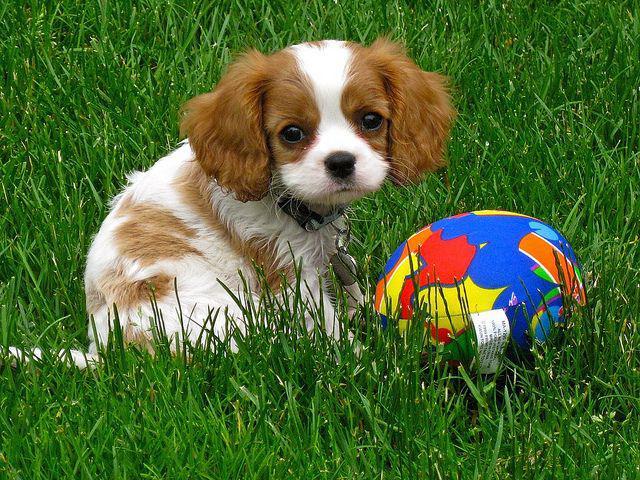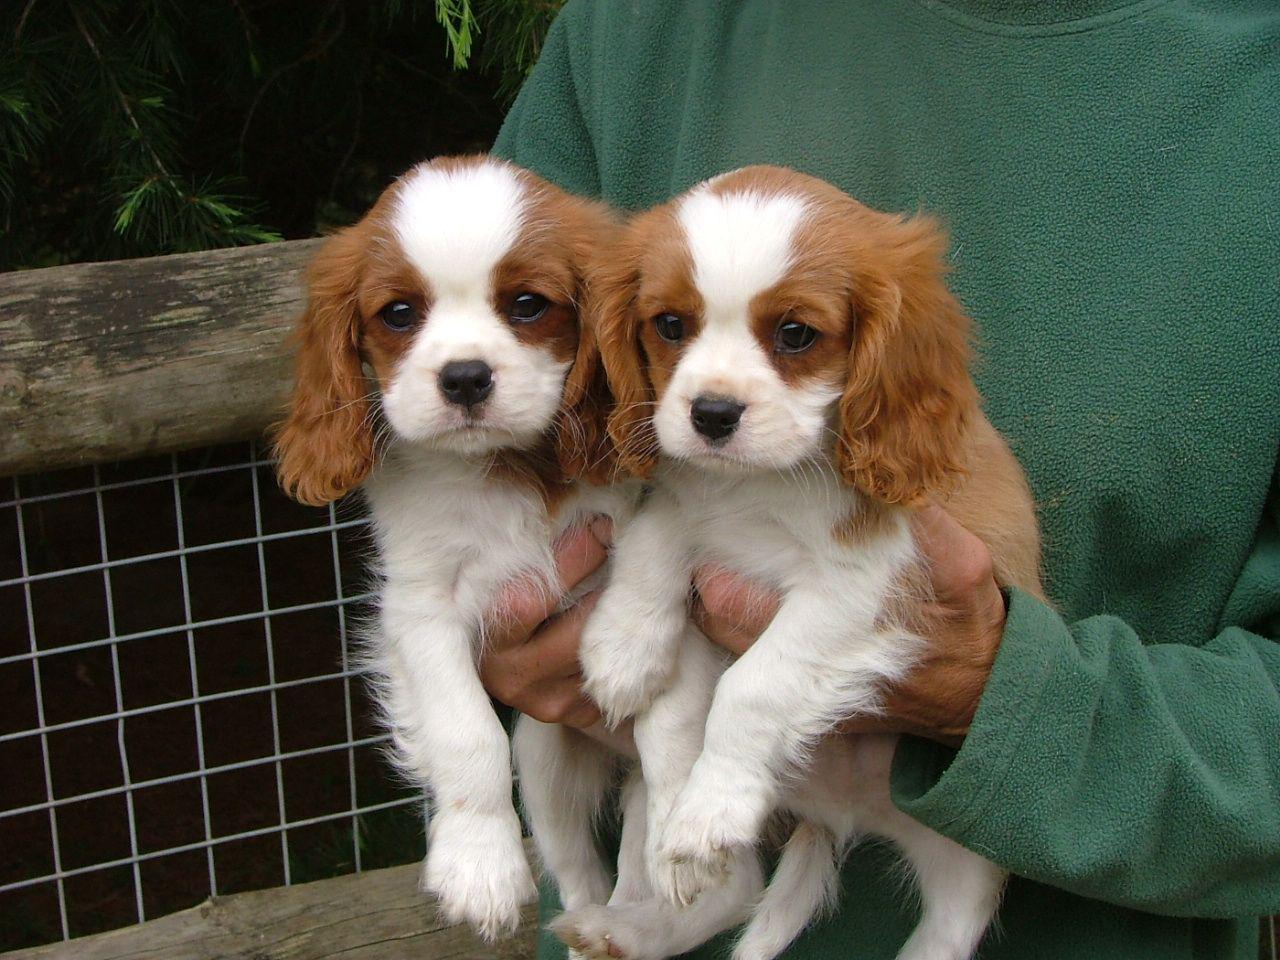The first image is the image on the left, the second image is the image on the right. Assess this claim about the two images: "There is a dog resting in the grass". Correct or not? Answer yes or no. Yes. The first image is the image on the left, the second image is the image on the right. Analyze the images presented: Is the assertion "The right image contains more dogs than the left image." valid? Answer yes or no. Yes. 